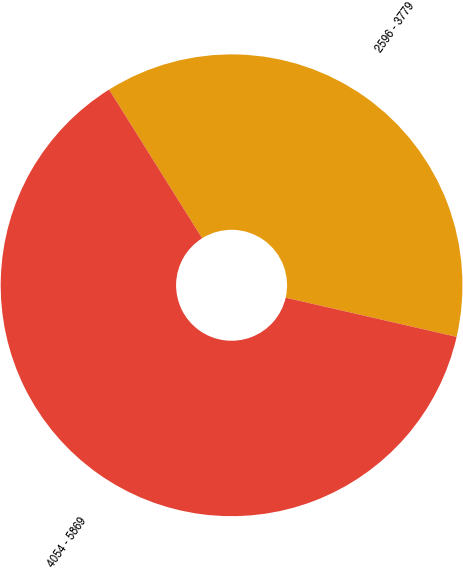<chart> <loc_0><loc_0><loc_500><loc_500><pie_chart><fcel>2596 - 3779<fcel>4054 - 5869<nl><fcel>37.49%<fcel>62.51%<nl></chart> 